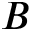Convert formula to latex. <formula><loc_0><loc_0><loc_500><loc_500>B</formula> 